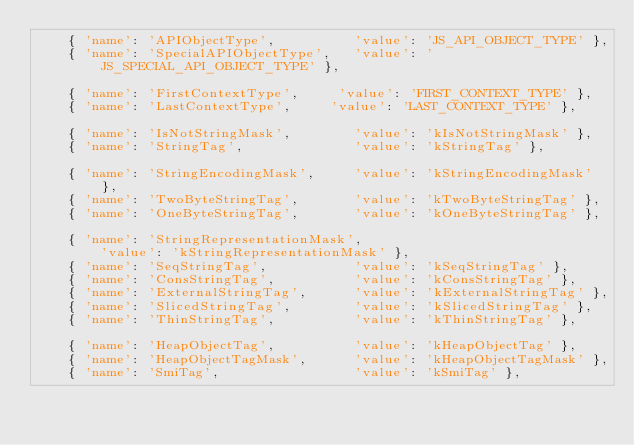<code> <loc_0><loc_0><loc_500><loc_500><_Python_>    { 'name': 'APIObjectType',          'value': 'JS_API_OBJECT_TYPE' },
    { 'name': 'SpecialAPIObjectType',   'value': 'JS_SPECIAL_API_OBJECT_TYPE' },

    { 'name': 'FirstContextType',     'value': 'FIRST_CONTEXT_TYPE' },
    { 'name': 'LastContextType',     'value': 'LAST_CONTEXT_TYPE' },

    { 'name': 'IsNotStringMask',        'value': 'kIsNotStringMask' },
    { 'name': 'StringTag',              'value': 'kStringTag' },

    { 'name': 'StringEncodingMask',     'value': 'kStringEncodingMask' },
    { 'name': 'TwoByteStringTag',       'value': 'kTwoByteStringTag' },
    { 'name': 'OneByteStringTag',       'value': 'kOneByteStringTag' },

    { 'name': 'StringRepresentationMask',
        'value': 'kStringRepresentationMask' },
    { 'name': 'SeqStringTag',           'value': 'kSeqStringTag' },
    { 'name': 'ConsStringTag',          'value': 'kConsStringTag' },
    { 'name': 'ExternalStringTag',      'value': 'kExternalStringTag' },
    { 'name': 'SlicedStringTag',        'value': 'kSlicedStringTag' },
    { 'name': 'ThinStringTag',          'value': 'kThinStringTag' },

    { 'name': 'HeapObjectTag',          'value': 'kHeapObjectTag' },
    { 'name': 'HeapObjectTagMask',      'value': 'kHeapObjectTagMask' },
    { 'name': 'SmiTag',                 'value': 'kSmiTag' },</code> 